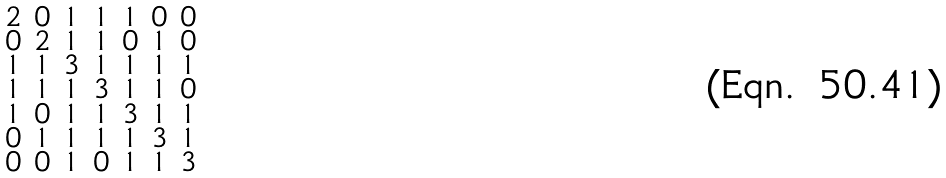Convert formula to latex. <formula><loc_0><loc_0><loc_500><loc_500>\begin{smallmatrix} 2 & 0 & 1 & 1 & 1 & 0 & 0 \\ 0 & 2 & 1 & 1 & 0 & 1 & 0 \\ 1 & 1 & 3 & 1 & 1 & 1 & 1 \\ 1 & 1 & 1 & 3 & 1 & 1 & 0 \\ 1 & 0 & 1 & 1 & 3 & 1 & 1 \\ 0 & 1 & 1 & 1 & 1 & 3 & 1 \\ 0 & 0 & 1 & 0 & 1 & 1 & 3 \end{smallmatrix}</formula> 